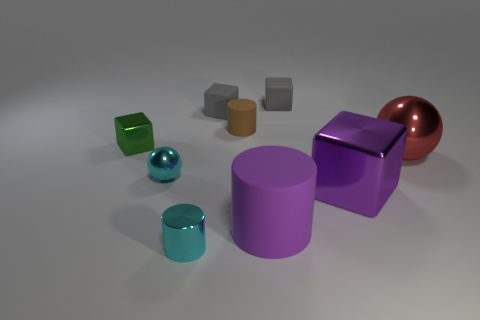Does the big cube have the same color as the big rubber cylinder?
Your answer should be very brief. Yes. There is a purple rubber thing that is the same size as the purple metallic block; what is its shape?
Your answer should be very brief. Cylinder. There is a matte cylinder behind the small metal object behind the red object in front of the tiny rubber cylinder; what is its color?
Give a very brief answer. Brown. How many things are large objects in front of the purple shiny object or tiny yellow matte blocks?
Provide a short and direct response. 1. What is the material of the cylinder that is the same size as the brown thing?
Offer a very short reply. Metal. There is a tiny cylinder to the left of the tiny gray thing that is left of the tiny cylinder behind the red metallic thing; what is it made of?
Your answer should be very brief. Metal. What is the color of the large matte cylinder?
Keep it short and to the point. Purple. How many small objects are either red balls or purple rubber things?
Offer a terse response. 0. There is a small thing that is the same color as the tiny metal cylinder; what is it made of?
Your answer should be compact. Metal. Is the material of the big thing that is behind the cyan sphere the same as the block that is in front of the tiny green shiny cube?
Provide a short and direct response. Yes. 